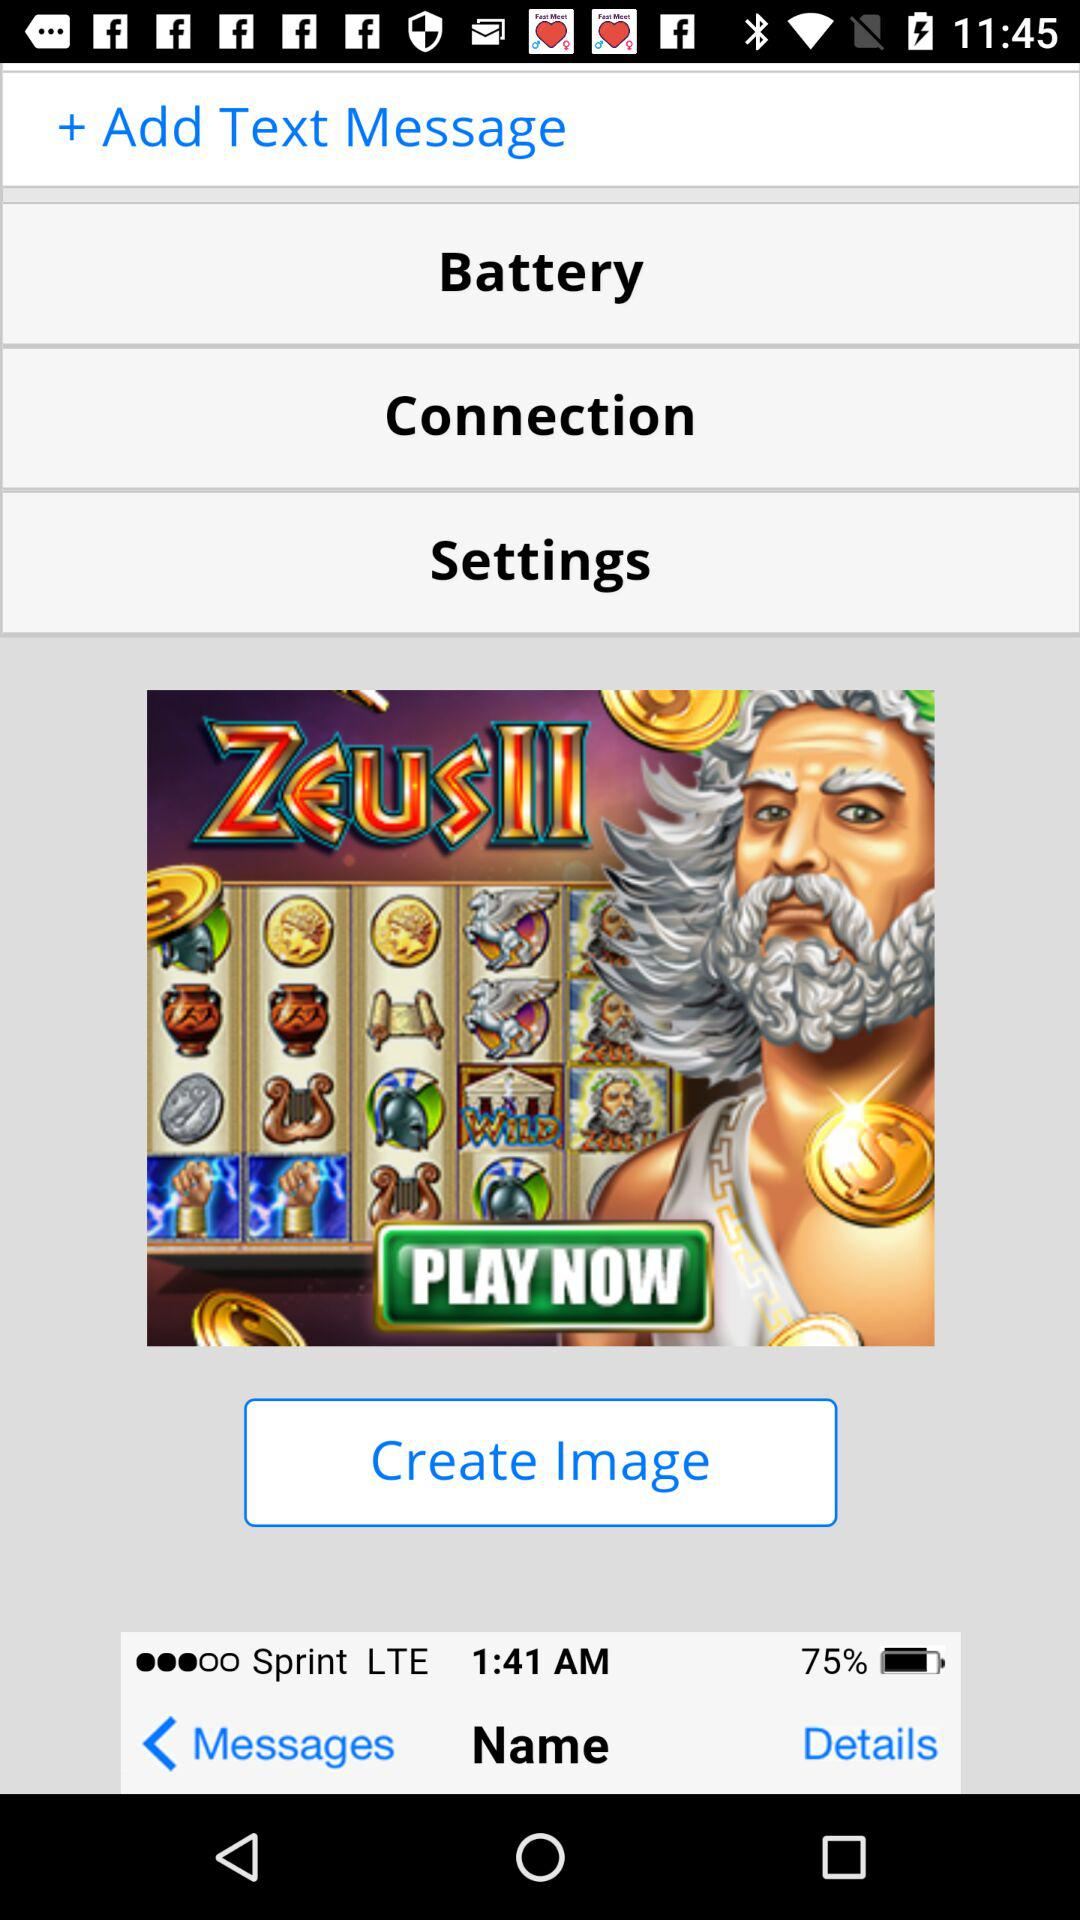What is the percentage of battery life remaining?
Answer the question using a single word or phrase. 75% 